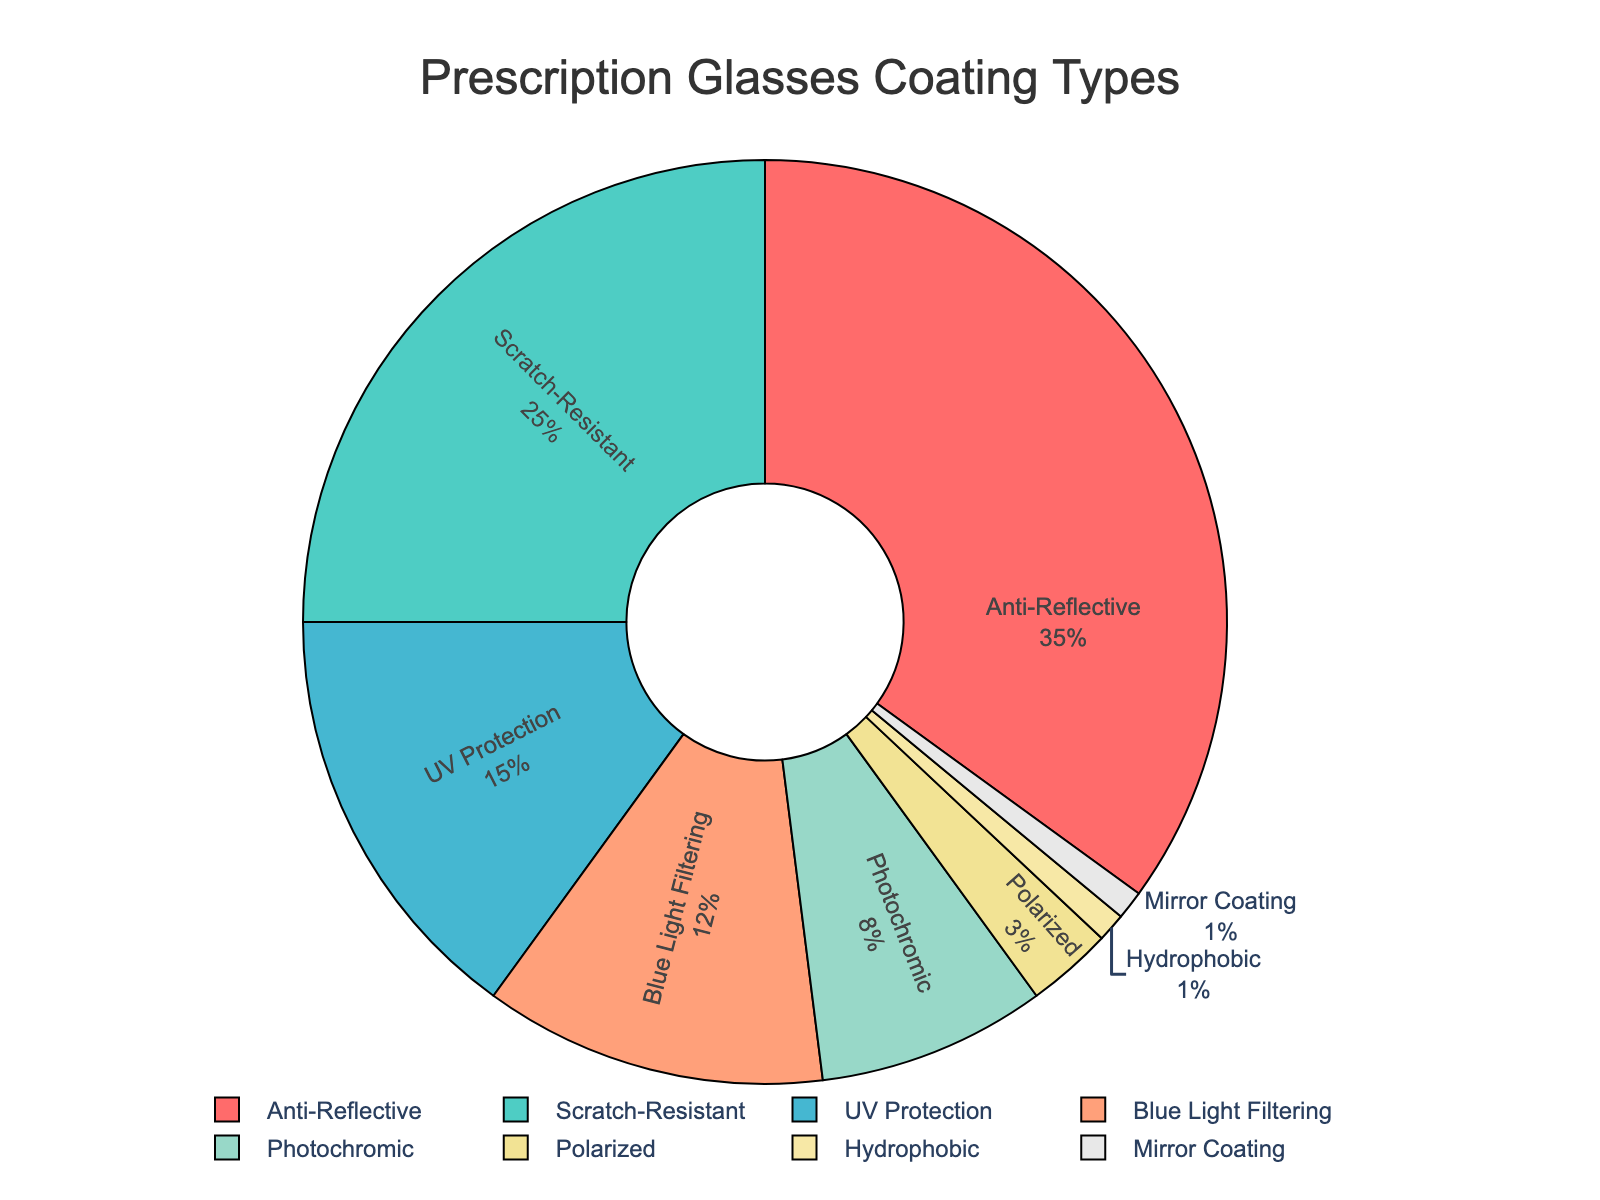What percentage of prescription glasses requested have Anti-Reflective coating? The pie chart visually shows that the slice corresponding to Anti-Reflective coating is labeled with 35%. Therefore, the percentage of prescription glasses requested with Anti-Reflective coating is 35%.
Answer: 35% What is the combined percentage of prescription glasses with Anti-Reflective and Scratch-Resistant coatings? To find the combined percentage, add the percentage of Anti-Reflective (35%) and Scratch-Resistant (25%) coatings: 35% + 25% = 60%.
Answer: 60% Which lens coating type has the lowest percentage requested? By looking at the pie chart, the smallest slices are for Hydrophobic and Mirror Coating, both labeled with 1%. Therefore, the lowest percentage requested is for both Hydrophobic and Mirror Coating.
Answer: Hydrophobic and Mirror Coating (1%) Is the percentage of UV Protection coating requests greater than the percentage of Blue Light Filtering coating requests? The pie chart shows the percentage of UV Protection coating as 15%, while Blue Light Filtering is 12%. Since 15% is greater than 12%, the answer is yes.
Answer: Yes What is the difference between the percentage of prescription glasses with Blue Light Filtering coating and those with Polarized coating? Subtract the percentage of Polarized coating (3%) from the percentage of Blue Light Filtering coating (12%): 12% - 3% = 9%.
Answer: 9% Which coating type represents the second most requested percentage of prescription glasses? By observing the pie chart, the second largest slice corresponds to Scratch-Resistant coating, labeled with 25%. Therefore, the second most requested coating type is Scratch-Resistant.
Answer: Scratch-Resistant (25%) Are Photochromic coatings more requested than Polarized coatings? The pie chart shows that the percentage for Photochromic coatings is 8%, whereas Polarized coatings are 3%. Since 8% is greater than 3%, the answer is yes.
Answer: Yes What is the total percentage of all prescription glasses with coatings other than Anti-Reflective? To find the total percentage, subtract the Anti-Reflective percentage (35%) from 100%: 100% - 35% = 65%.
Answer: 65% If an equal percentage of prescription glasses had UV Protection as well as Blue Light Filtering coatings, what would their individual percentage requests be? Combine the current percentages of UV Protection (15%) and Blue Light Filtering (12%), then divide by 2: (15% + 12%) / 2 = 27% / 2 = 13.5%.
Answer: 13.5% What is the sum of the percentages of coatings that are requested in single digits? Add the percentages of Photochromic (8%), Polarized (3%), Hydrophobic (1%), and Mirror Coating (1%): 8% + 3% + 1% + 1% = 13%.
Answer: 13% 